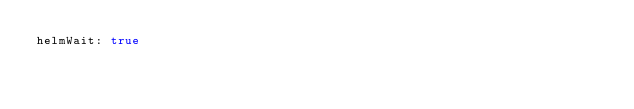<code> <loc_0><loc_0><loc_500><loc_500><_YAML_>helmWait: true
</code> 